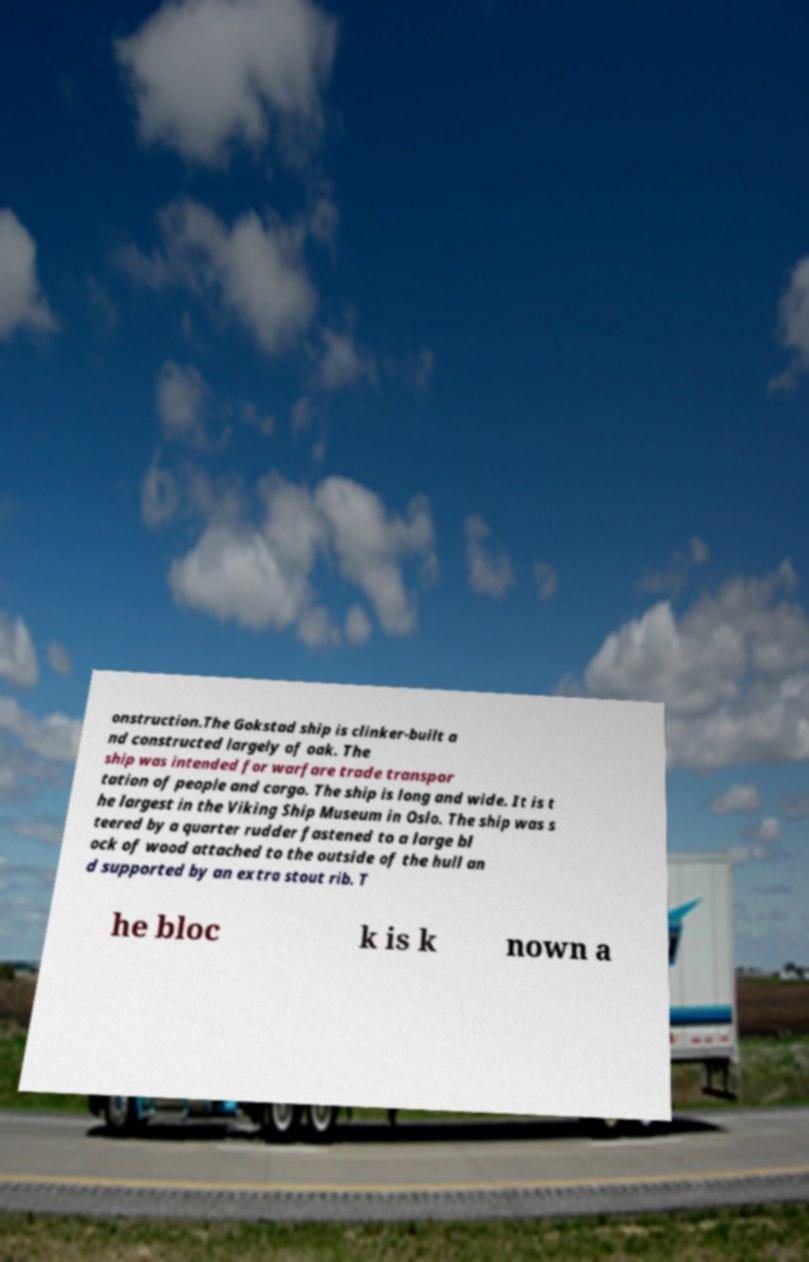There's text embedded in this image that I need extracted. Can you transcribe it verbatim? onstruction.The Gokstad ship is clinker-built a nd constructed largely of oak. The ship was intended for warfare trade transpor tation of people and cargo. The ship is long and wide. It is t he largest in the Viking Ship Museum in Oslo. The ship was s teered by a quarter rudder fastened to a large bl ock of wood attached to the outside of the hull an d supported by an extra stout rib. T he bloc k is k nown a 